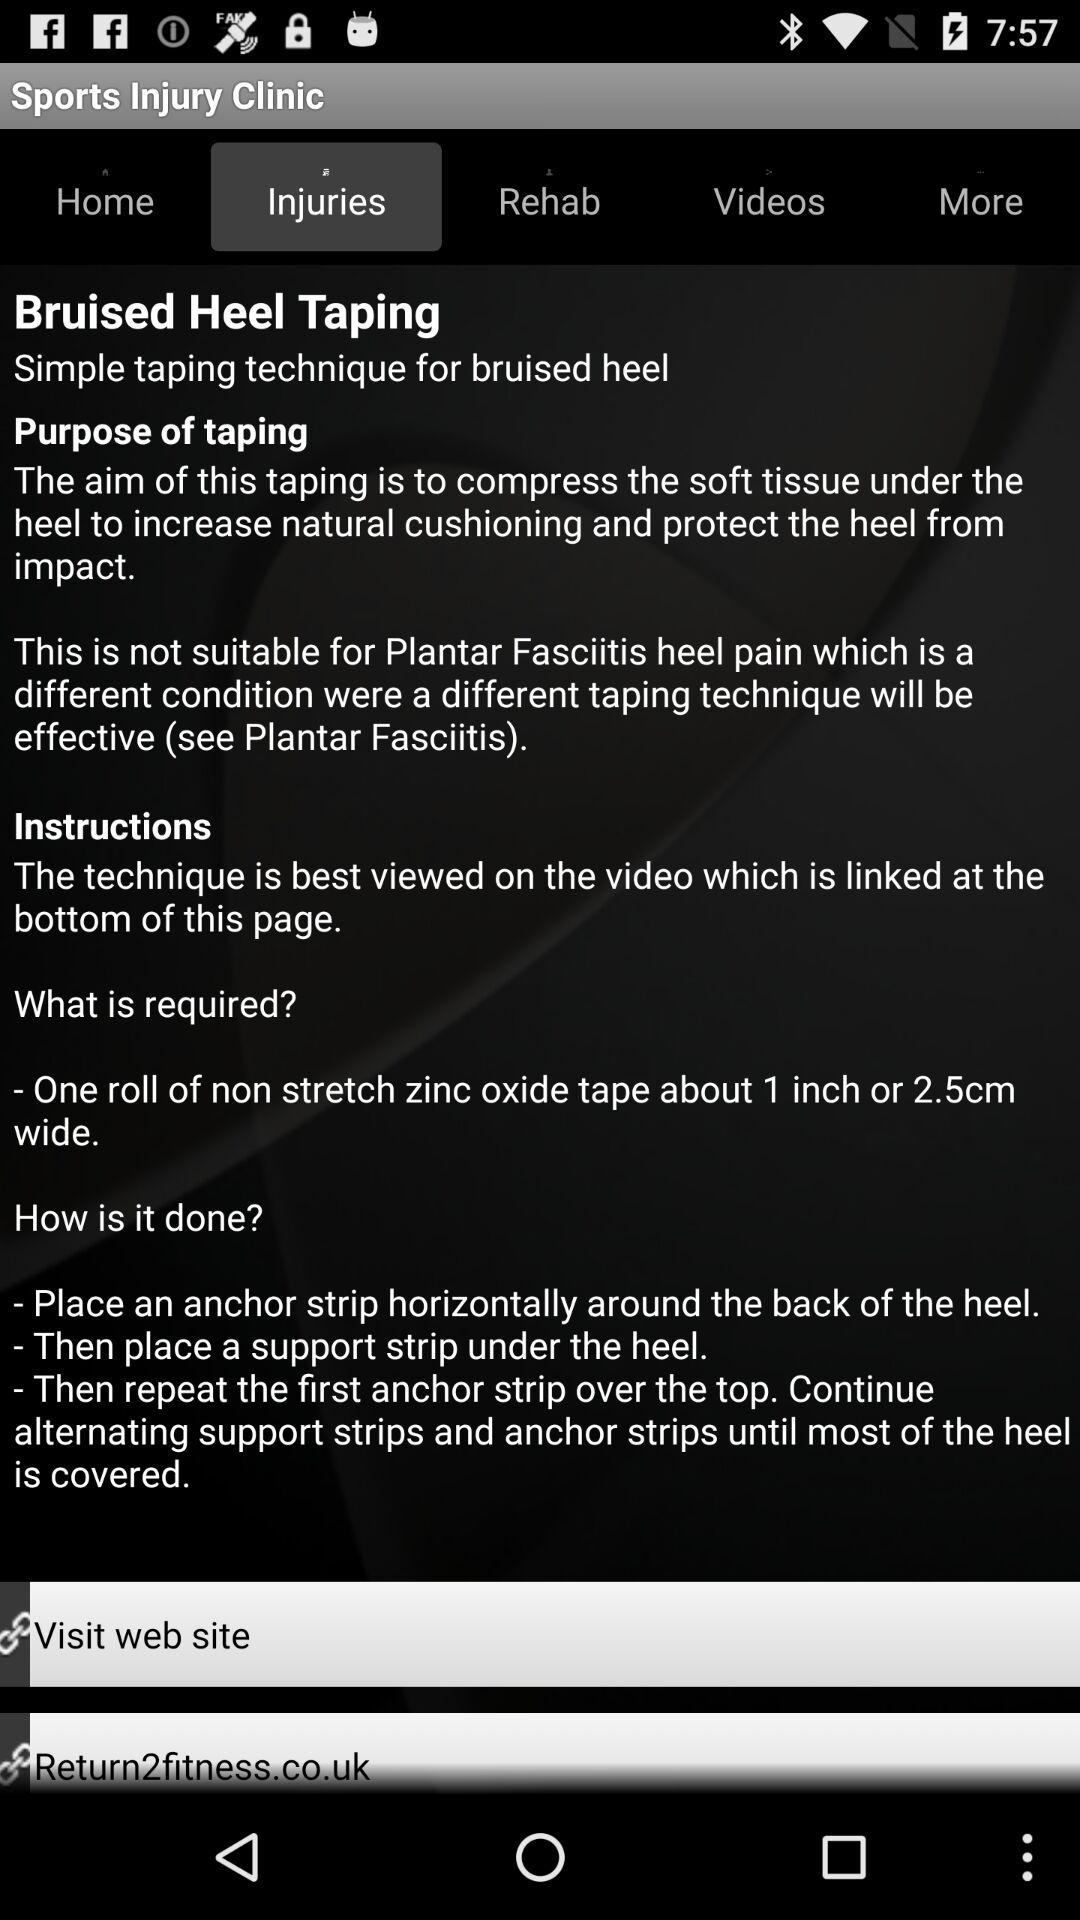Which tab is selected? The selected tab is "Injuries". 